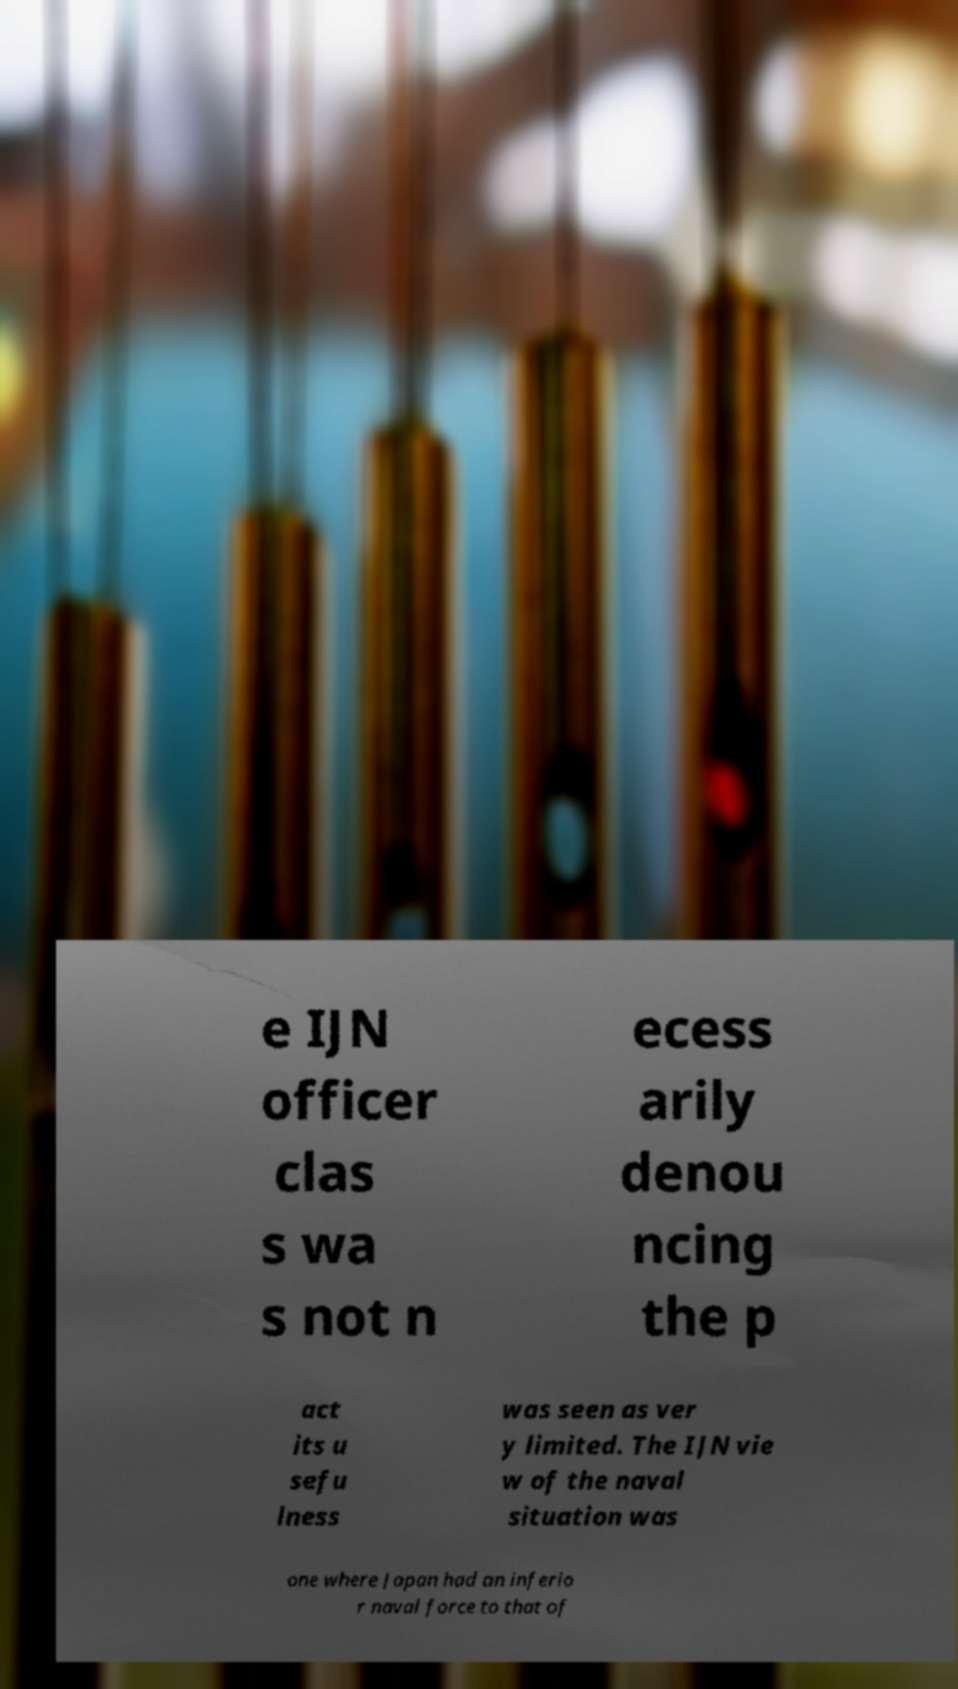I need the written content from this picture converted into text. Can you do that? e IJN officer clas s wa s not n ecess arily denou ncing the p act its u sefu lness was seen as ver y limited. The IJN vie w of the naval situation was one where Japan had an inferio r naval force to that of 